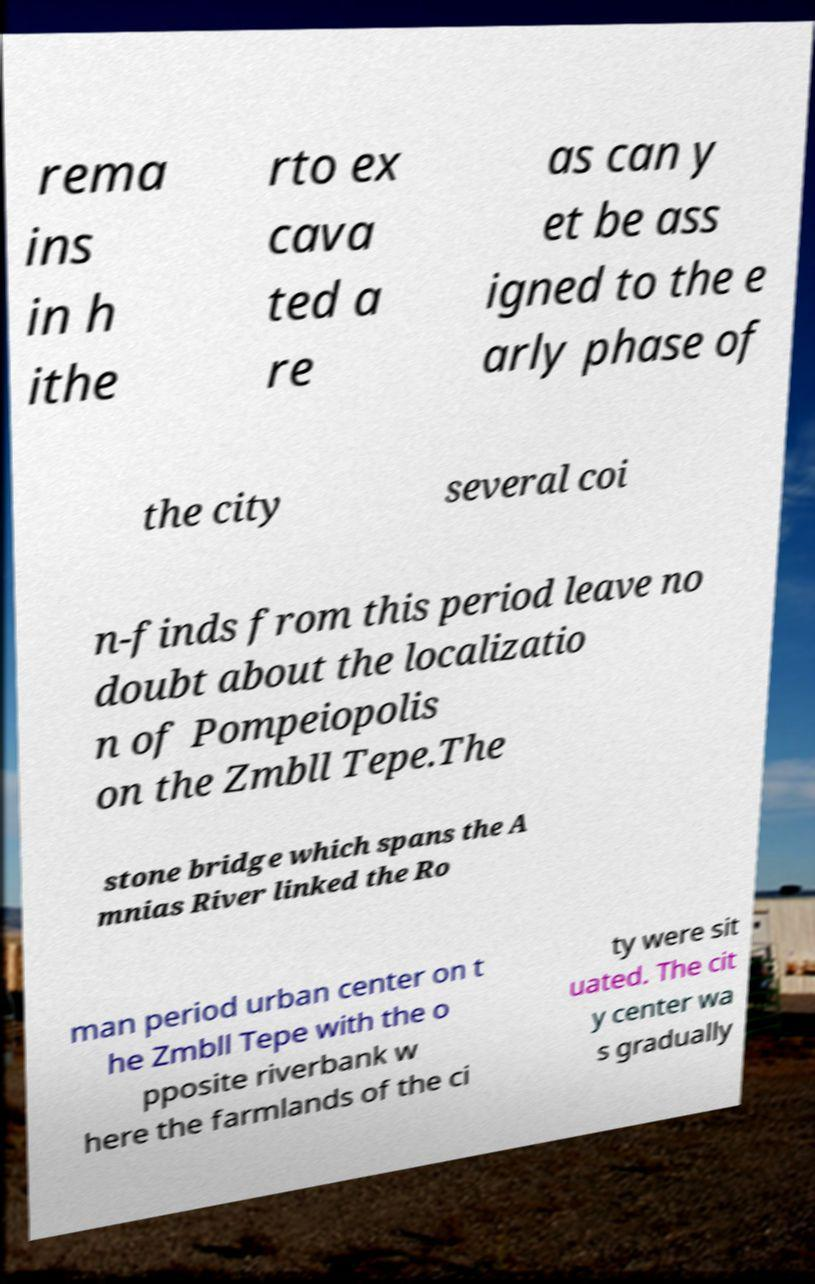Can you read and provide the text displayed in the image?This photo seems to have some interesting text. Can you extract and type it out for me? rema ins in h ithe rto ex cava ted a re as can y et be ass igned to the e arly phase of the city several coi n-finds from this period leave no doubt about the localizatio n of Pompeiopolis on the Zmbll Tepe.The stone bridge which spans the A mnias River linked the Ro man period urban center on t he Zmbll Tepe with the o pposite riverbank w here the farmlands of the ci ty were sit uated. The cit y center wa s gradually 